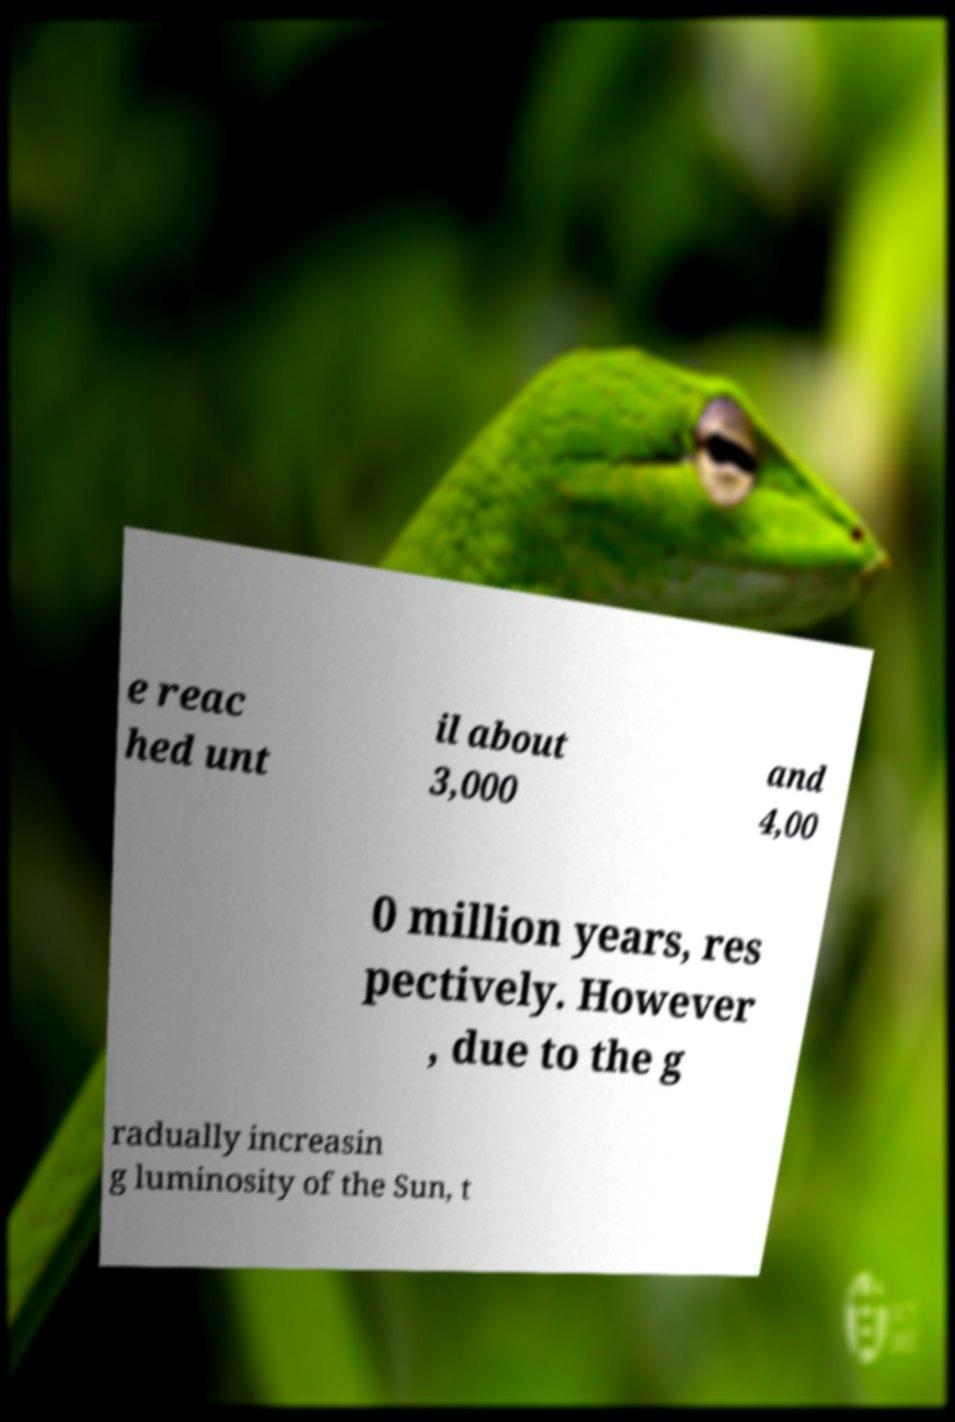Please identify and transcribe the text found in this image. e reac hed unt il about 3,000 and 4,00 0 million years, res pectively. However , due to the g radually increasin g luminosity of the Sun, t 